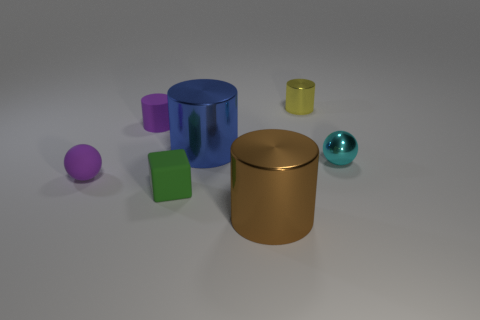Add 2 tiny rubber balls. How many objects exist? 9 Subtract all cyan balls. How many balls are left? 1 Subtract 3 cylinders. How many cylinders are left? 1 Subtract all blue metal cylinders. How many cylinders are left? 3 Subtract 0 yellow spheres. How many objects are left? 7 Subtract all blocks. How many objects are left? 6 Subtract all brown cylinders. Subtract all green blocks. How many cylinders are left? 3 Subtract all gray blocks. How many blue cylinders are left? 1 Subtract all small gray cylinders. Subtract all large objects. How many objects are left? 5 Add 7 big metallic cylinders. How many big metallic cylinders are left? 9 